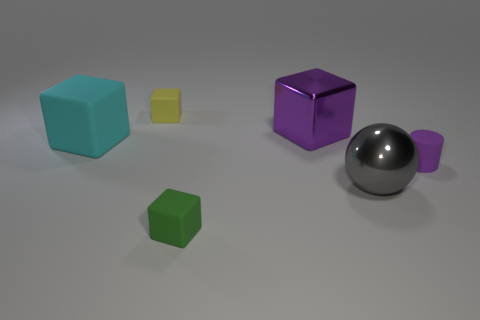Add 2 green metal cylinders. How many objects exist? 8 Subtract all blocks. How many objects are left? 2 Subtract 0 yellow cylinders. How many objects are left? 6 Subtract all green rubber objects. Subtract all yellow rubber blocks. How many objects are left? 4 Add 1 big purple cubes. How many big purple cubes are left? 2 Add 5 big gray metal objects. How many big gray metal objects exist? 6 